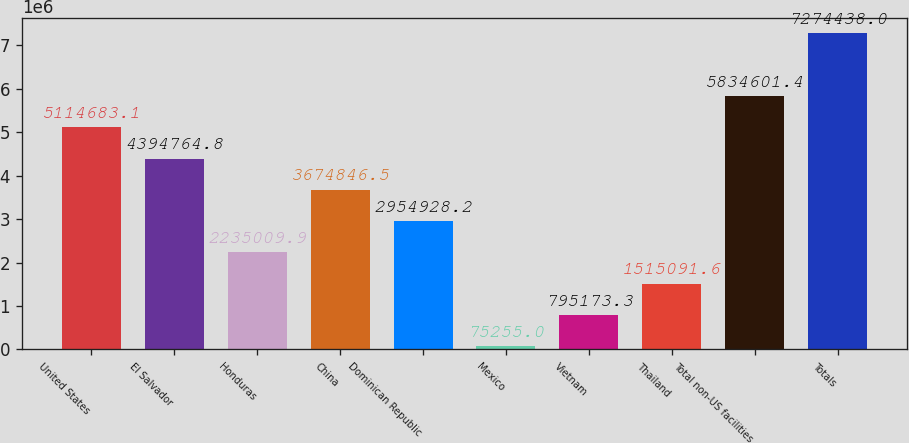Convert chart. <chart><loc_0><loc_0><loc_500><loc_500><bar_chart><fcel>United States<fcel>El Salvador<fcel>Honduras<fcel>China<fcel>Dominican Republic<fcel>Mexico<fcel>Vietnam<fcel>Thailand<fcel>Total non-US facilities<fcel>Totals<nl><fcel>5.11468e+06<fcel>4.39476e+06<fcel>2.23501e+06<fcel>3.67485e+06<fcel>2.95493e+06<fcel>75255<fcel>795173<fcel>1.51509e+06<fcel>5.8346e+06<fcel>7.27444e+06<nl></chart> 